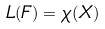<formula> <loc_0><loc_0><loc_500><loc_500>L ( F ) = \chi ( X )</formula> 